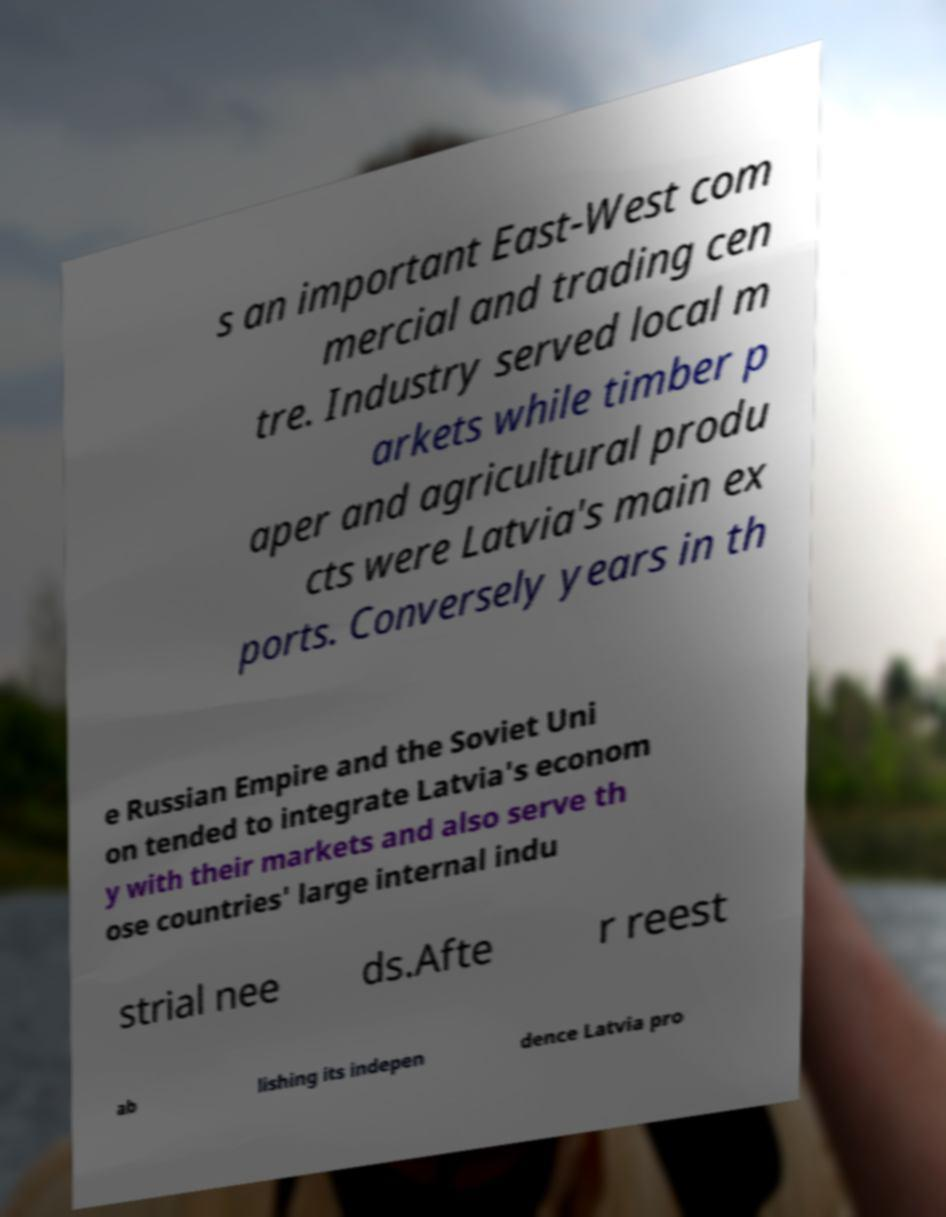What messages or text are displayed in this image? I need them in a readable, typed format. s an important East-West com mercial and trading cen tre. Industry served local m arkets while timber p aper and agricultural produ cts were Latvia's main ex ports. Conversely years in th e Russian Empire and the Soviet Uni on tended to integrate Latvia's econom y with their markets and also serve th ose countries' large internal indu strial nee ds.Afte r reest ab lishing its indepen dence Latvia pro 